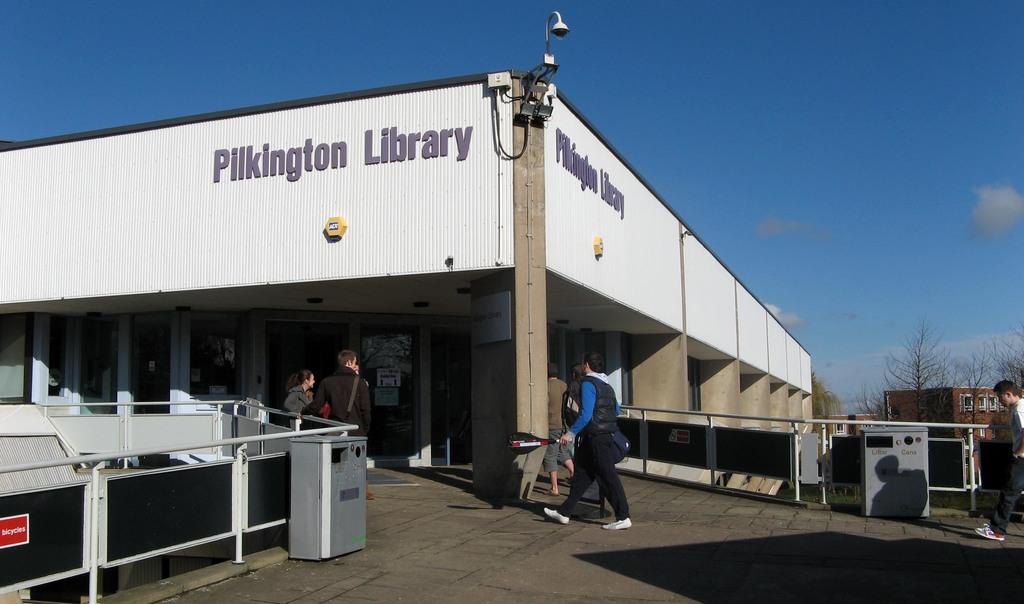What type of structures can be seen in the image? There are buildings in the image. What objects are present in the image that might be used for displaying information or advertisements? There are boards in the image. What feature of the buildings can be used for entering or exiting? There is a door in the image. What objects are present in the image that might be used for storage or transportation? There are boxes in the image. Are there any people visible in the image? Yes, there are persons in the image. What type of natural elements can be seen in the image? There are trees in the image. What is visible in the background of the image? The sky is visible in the background of the image, and there are clouds in the sky. What type of wound can be seen on the person in the image? There is no wound visible on any person in the image. What type of apple is being offered by the person in the image? There is no apple present in the image, and no one is offering anything. 